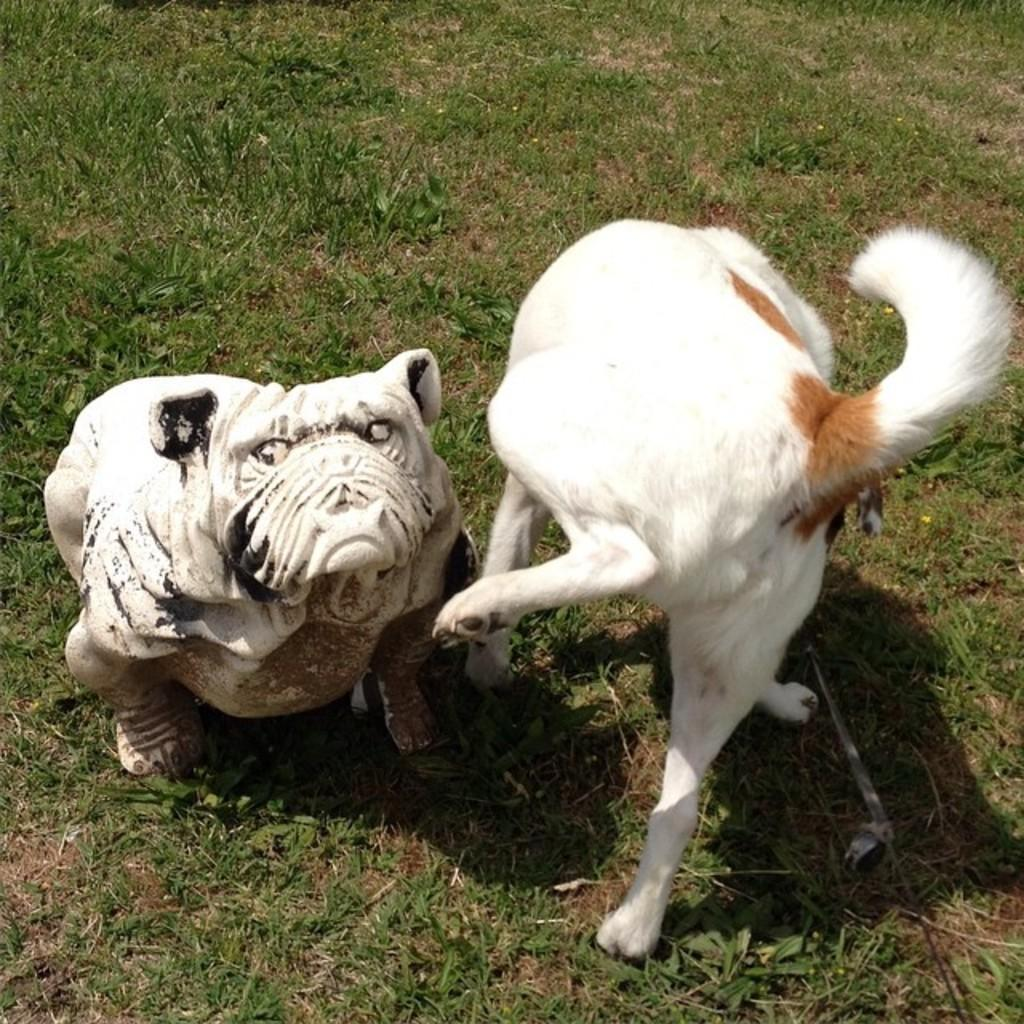What is the main subject in the center of the image? There is a statue and a dog in the center of the image. Can you describe the statue in the image? Unfortunately, the facts provided do not give any details about the statue. What can be seen in the background of the image? There is grass in the background of the image. How many children are playing in the background of the image? There is no mention of children in the image, so we cannot determine the number of children present. 